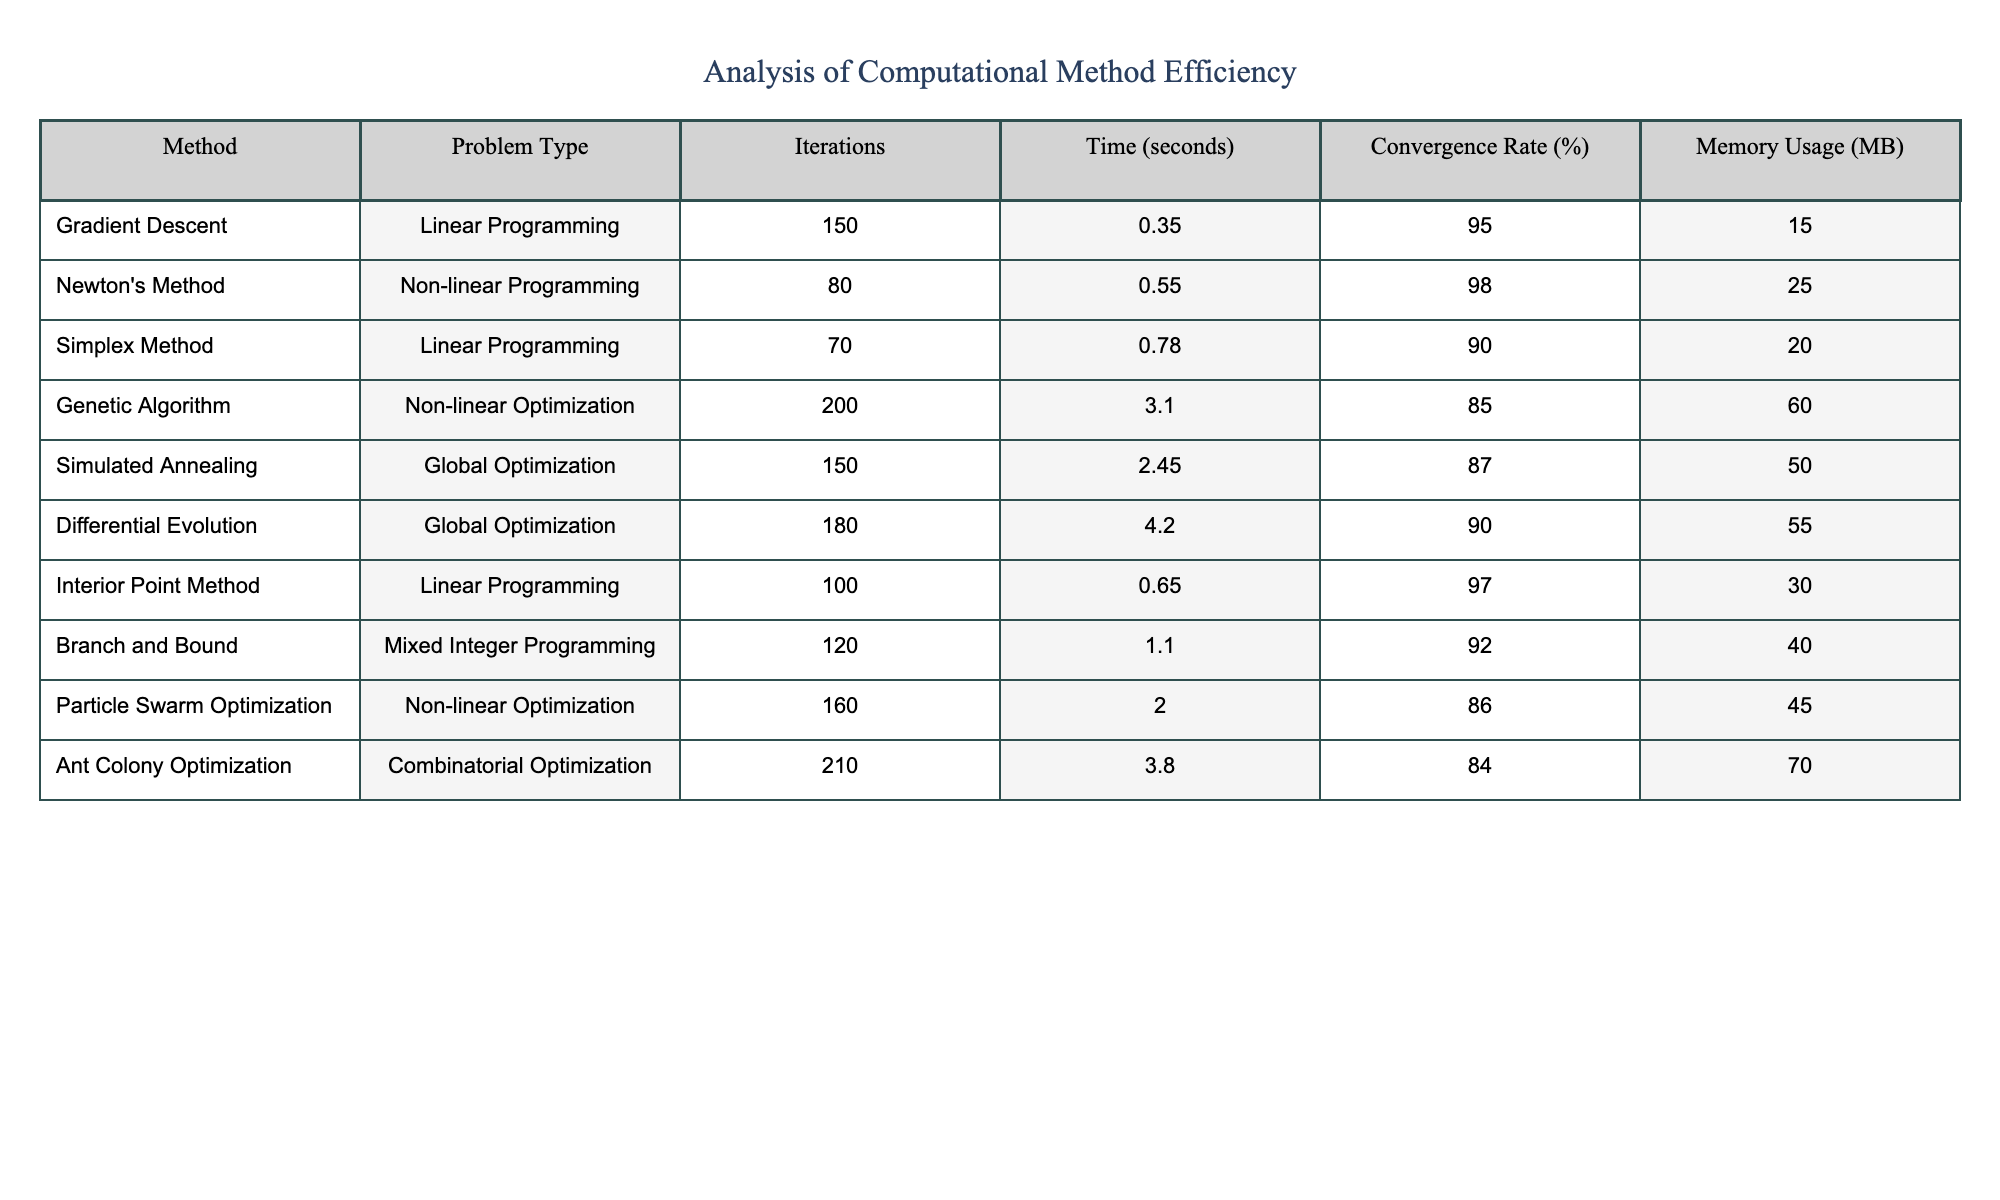What is the convergence rate of Newton's Method? In the table, looking at the row for Newton's Method, the convergence rate listed is 98%.
Answer: 98% Which method had the highest memory usage? By inspecting the memory usage column, Ant Colony Optimization has the highest value at 70 MB.
Answer: 70 MB What is the average time taken by linear programming methods? The linear programming methods listed are Gradient Descent, Simplex Method, and Interior Point Method with times of 0.35, 0.78, and 0.65 seconds. Averaging these gives (0.35 + 0.78 + 0.65) / 3 = 0.5933 seconds.
Answer: 0.5933 seconds Is the time taken by the Genetic Algorithm greater than that of the Differential Evolution method? The time for Genetic Algorithm is 3.10 seconds and for Differential Evolution is 4.20 seconds, so 3.10 is less than 4.20. Thus, the statement is false.
Answer: No What is the difference in convergence rates between the Particle Swarm Optimization and the Genetic Algorithm? Particle Swarm Optimization has a convergence rate of 86%, while the Genetic Algorithm has 85%. The difference is 86 - 85 = 1%.
Answer: 1% Which optimization method is the fastest among all listed methods? Referring to the time column, Gradient Descent at 0.35 seconds is the fastest.
Answer: 0.35 seconds What can be concluded about methods that have a convergence rate below 90%? The methods with below 90% convergence rate are Simplex Method (90%), Genetic Algorithm (85%), Simulated Annealing (87%), Differential Evolution (90%), and Ant Colony Optimization (84%). This shows that 3 out of the 5 listed methods are below 90%.
Answer: 3 methods What is the total number of iterations across all methods? Summing up all the iterations: 150 + 80 + 70 + 200 + 150 + 180 + 100 + 120 + 160 + 210 gives a total of 1290 iterations.
Answer: 1290 iterations Is the time taken by the Simplex Method greater than the Interior Point Method? The Simplex Method takes 0.78 seconds, while the Interior Point Method takes 0.65 seconds, so Simplex Method is greater.
Answer: Yes Which method had the least iterations and what type of problem did it solve? The method with the least iterations is the Simplex Method with 70 iterations, and it solves Linear Programming problems.
Answer: Simplex Method, Linear Programming 